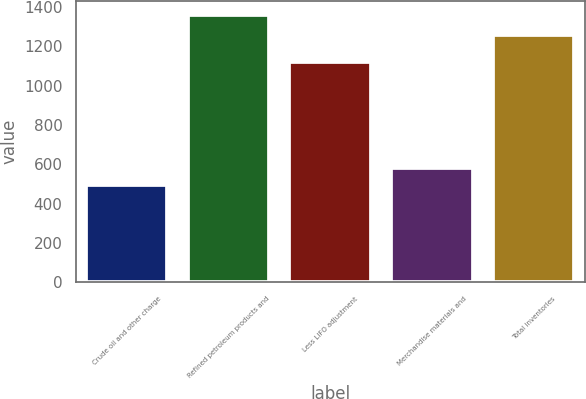Convert chart to OTSL. <chart><loc_0><loc_0><loc_500><loc_500><bar_chart><fcel>Crude oil and other charge<fcel>Refined petroleum products and<fcel>Less LIFO adjustment<fcel>Merchandise materials and<fcel>Total inventories<nl><fcel>493<fcel>1362<fcel>1123<fcel>579.9<fcel>1259<nl></chart> 